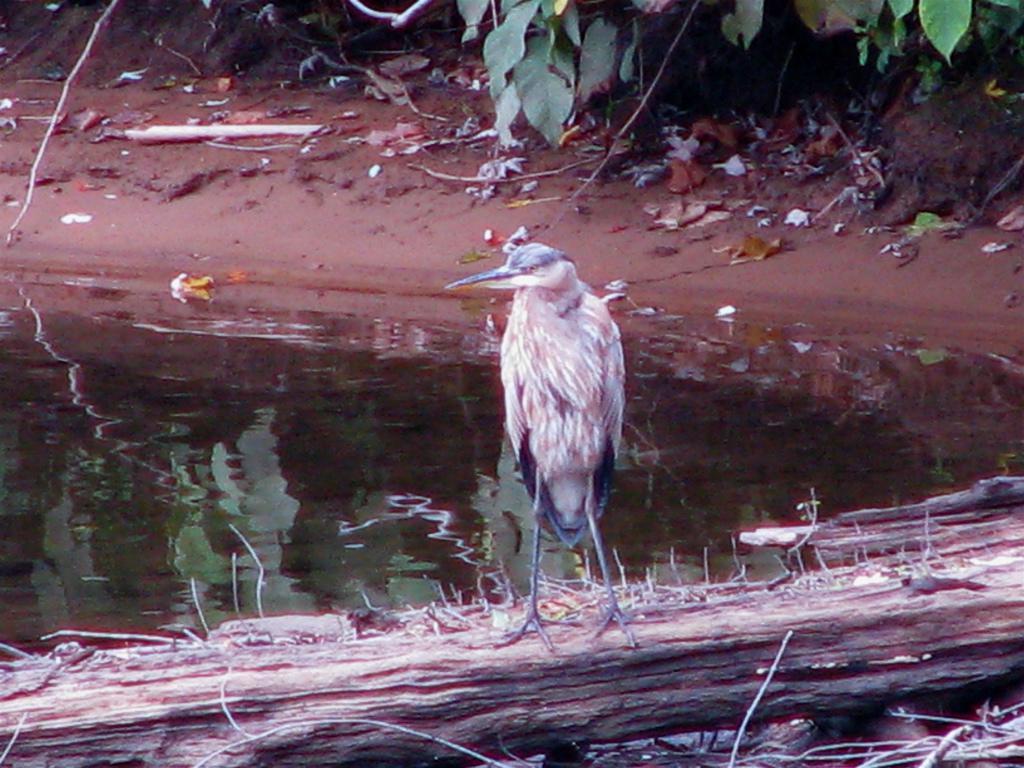In one or two sentences, can you explain what this image depicts? In the image there is a bird standing on a wood in a pond and there are plants on the shore. 